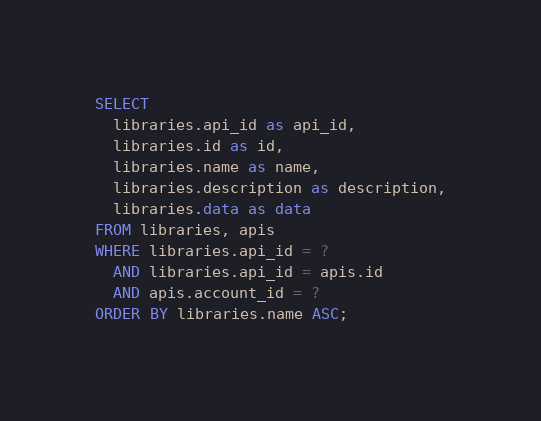Convert code to text. <code><loc_0><loc_0><loc_500><loc_500><_SQL_>SELECT
  libraries.api_id as api_id,
  libraries.id as id,
  libraries.name as name,
  libraries.description as description,
  libraries.data as data
FROM libraries, apis
WHERE libraries.api_id = ?
  AND libraries.api_id = apis.id
  AND apis.account_id = ?
ORDER BY libraries.name ASC;
</code> 